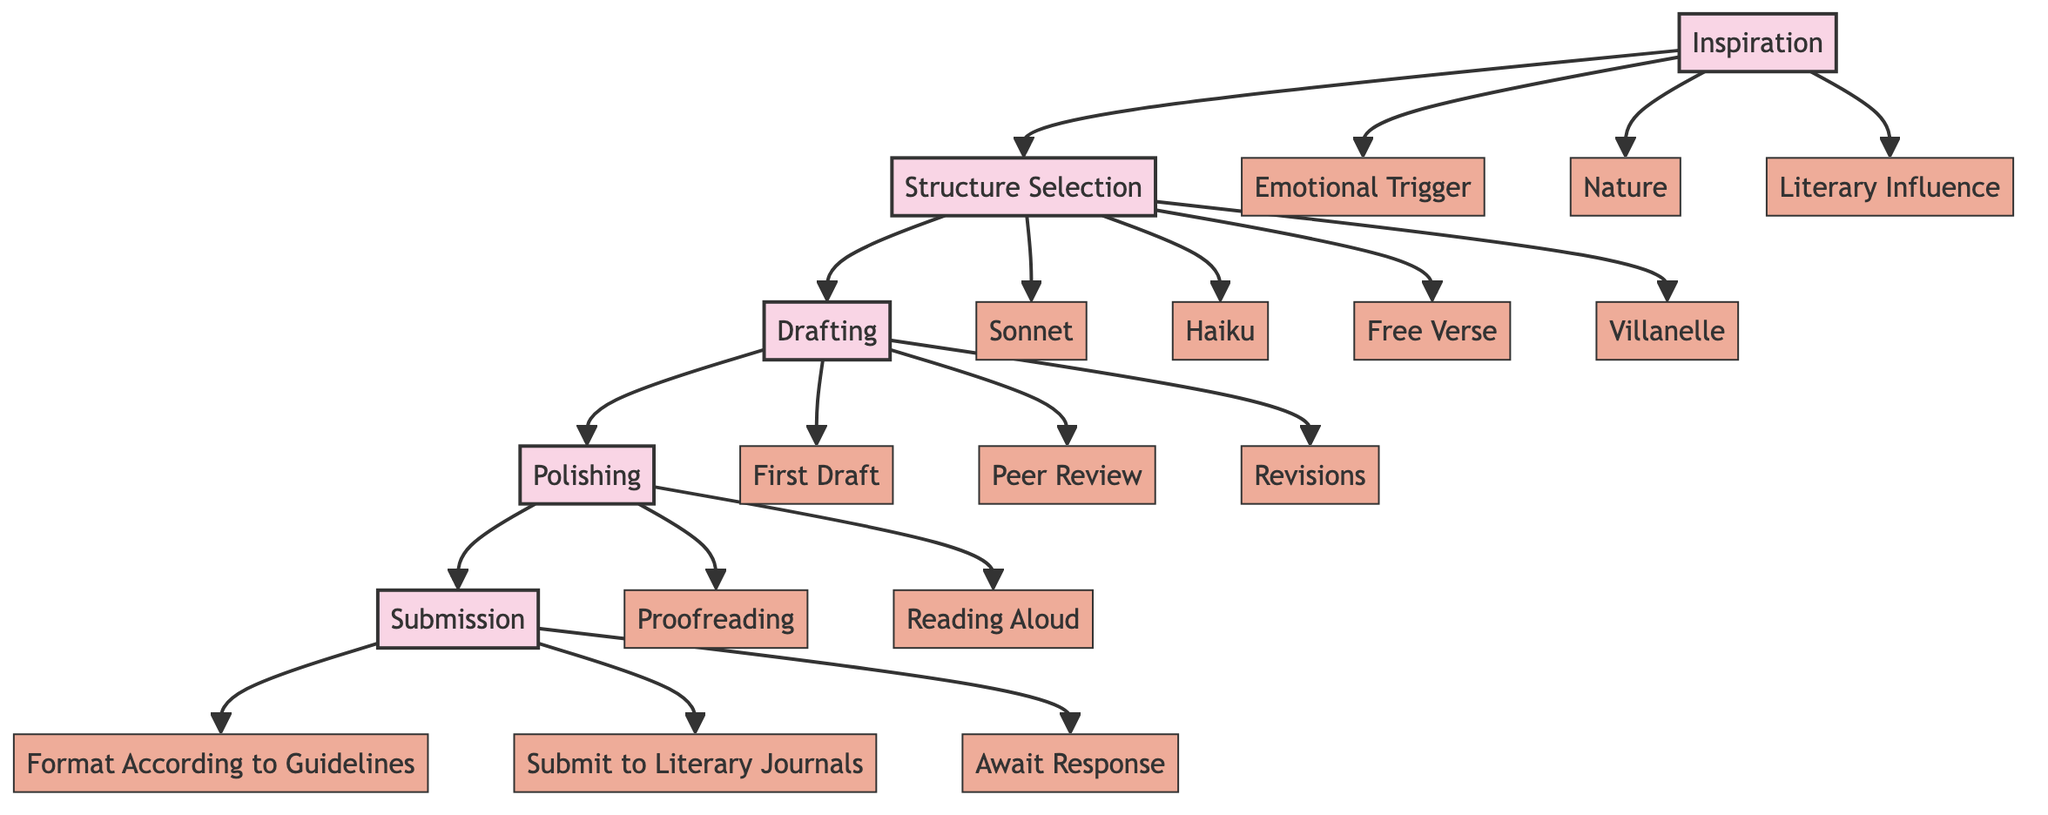What is the first step in the poetic process? The diagram clearly indicates that "Inspiration" is positioned as the first node, representing the initial spark or idea for the poetic work.
Answer: Inspiration How many subelements are under "Structure Selection"? There are four subelements listed under "Structure Selection," which include "Sonnet," "Haiku," "Free Verse," and "Villanelle."
Answer: 4 What are the two final steps before the poem is published? In the flow chart, the last two main nodes are "Polishing" followed by "Submission," showing the order leading to publication.
Answer: Polishing, Submission Which aspect relates to ensuring grammatical correctness? "Proofreading" is specifically highlighted under the "Polishing" node as the step dedicated to correcting grammatical errors and improving word choice.
Answer: Proofreading What happens after "Drafting" in the process? The flow chart illustrates that "Polishing" follows "Drafting," indicating that refinement of the draft is the next step after the initial writing.
Answer: Polishing What are examples of "Emotional Triggers"? The diagram lists "Emotional Trigger" as a subelement of "Inspiration," though examples are not explicitly provided here; it generally refers to emotions or experiences that ignite creative ideas.
Answer: Emotional Trigger Which poetic form has a 14-line structure? The "Sonnet," under "Structure Selection," is clearly labeled as a 14-line poem with a specific rhyme scheme, making it the correct answer.
Answer: Sonnet What does "Await Response" refer to? "Await Response" is the last subelement under "Submission," indicating the phase where the poet waits to hear back regarding the acceptance or rejection of their poem.
Answer: Await Response 